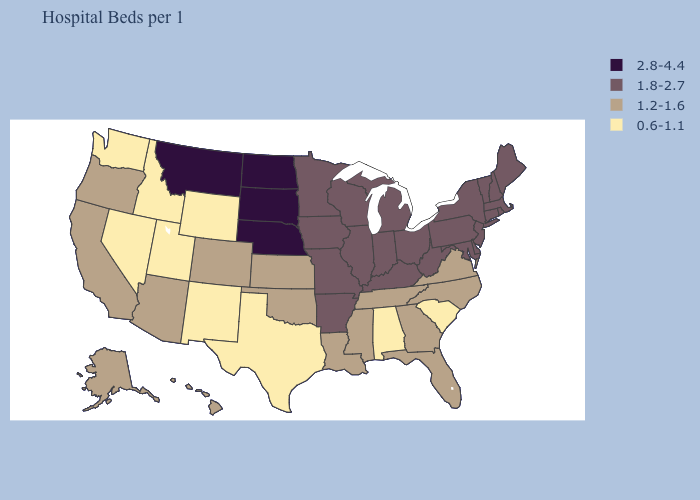What is the highest value in states that border Louisiana?
Write a very short answer. 1.8-2.7. Name the states that have a value in the range 1.2-1.6?
Give a very brief answer. Alaska, Arizona, California, Colorado, Florida, Georgia, Hawaii, Kansas, Louisiana, Mississippi, North Carolina, Oklahoma, Oregon, Tennessee, Virginia. Which states have the highest value in the USA?
Keep it brief. Montana, Nebraska, North Dakota, South Dakota. What is the value of Alaska?
Give a very brief answer. 1.2-1.6. What is the value of Idaho?
Answer briefly. 0.6-1.1. Name the states that have a value in the range 0.6-1.1?
Quick response, please. Alabama, Idaho, Nevada, New Mexico, South Carolina, Texas, Utah, Washington, Wyoming. What is the value of Alaska?
Short answer required. 1.2-1.6. Name the states that have a value in the range 1.8-2.7?
Concise answer only. Arkansas, Connecticut, Delaware, Illinois, Indiana, Iowa, Kentucky, Maine, Maryland, Massachusetts, Michigan, Minnesota, Missouri, New Hampshire, New Jersey, New York, Ohio, Pennsylvania, Rhode Island, Vermont, West Virginia, Wisconsin. What is the value of Missouri?
Write a very short answer. 1.8-2.7. Does Washington have the lowest value in the West?
Write a very short answer. Yes. Name the states that have a value in the range 2.8-4.4?
Quick response, please. Montana, Nebraska, North Dakota, South Dakota. Is the legend a continuous bar?
Concise answer only. No. Name the states that have a value in the range 1.8-2.7?
Short answer required. Arkansas, Connecticut, Delaware, Illinois, Indiana, Iowa, Kentucky, Maine, Maryland, Massachusetts, Michigan, Minnesota, Missouri, New Hampshire, New Jersey, New York, Ohio, Pennsylvania, Rhode Island, Vermont, West Virginia, Wisconsin. Name the states that have a value in the range 0.6-1.1?
Be succinct. Alabama, Idaho, Nevada, New Mexico, South Carolina, Texas, Utah, Washington, Wyoming. Name the states that have a value in the range 2.8-4.4?
Be succinct. Montana, Nebraska, North Dakota, South Dakota. 